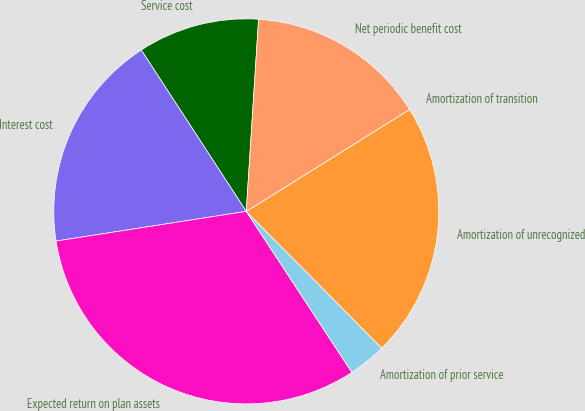<chart> <loc_0><loc_0><loc_500><loc_500><pie_chart><fcel>Service cost<fcel>Interest cost<fcel>Expected return on plan assets<fcel>Amortization of prior service<fcel>Amortization of unrecognized<fcel>Amortization of transition<fcel>Net periodic benefit cost<nl><fcel>10.2%<fcel>18.28%<fcel>31.78%<fcel>3.18%<fcel>21.46%<fcel>0.0%<fcel>15.1%<nl></chart> 